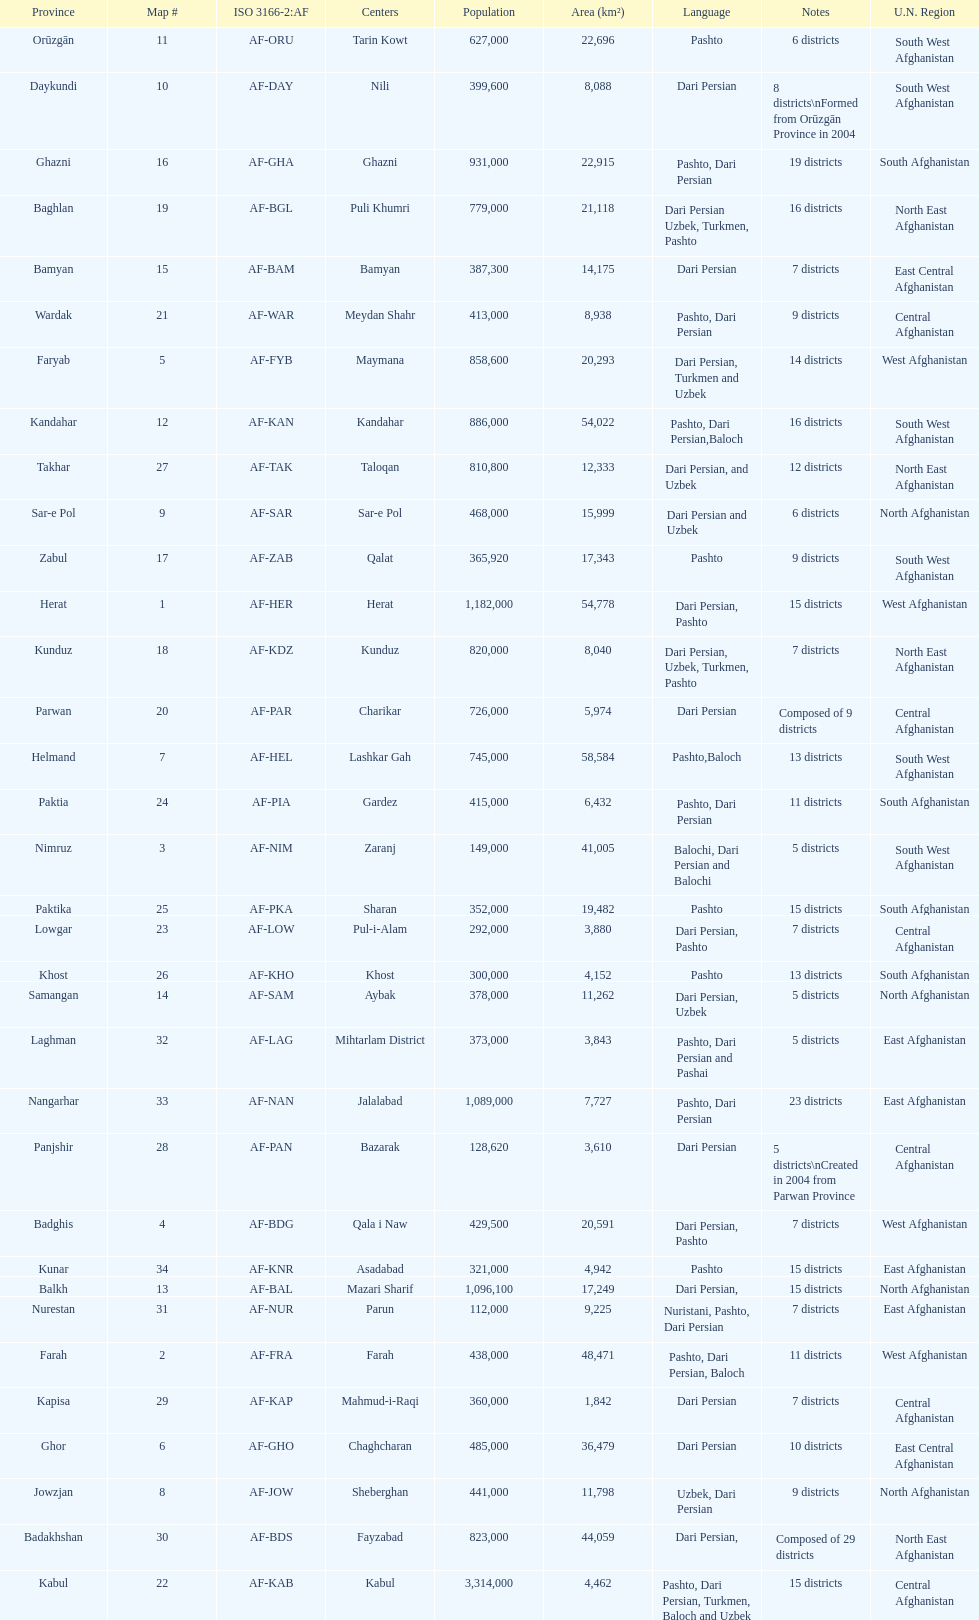How many provinces in afghanistan speak dari persian? 28. 